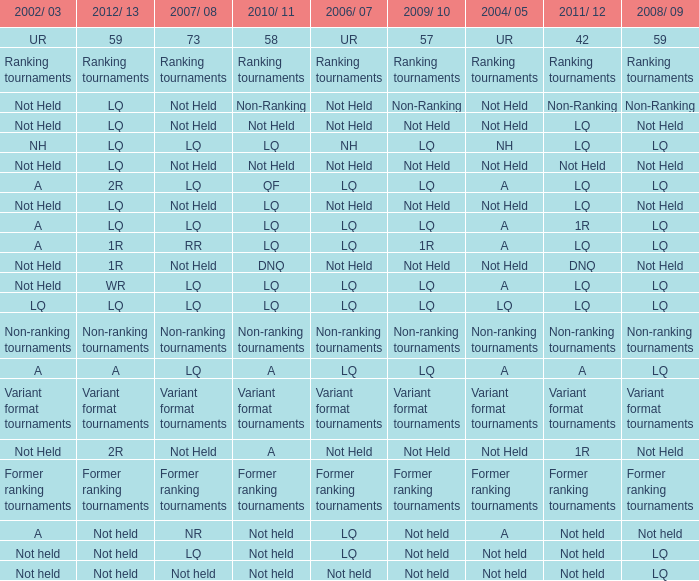Name the 2008/09 with 2004/05 of ranking tournaments Ranking tournaments. 